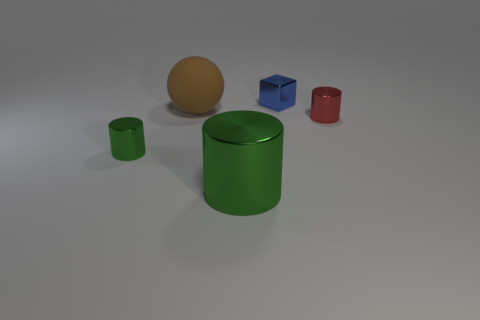Do the green cylinder that is to the left of the brown thing and the big green thing have the same size? No, the sizes differ; the green cylinder to the left of the brown sphere is noticeably smaller than the larger green cylinder. 